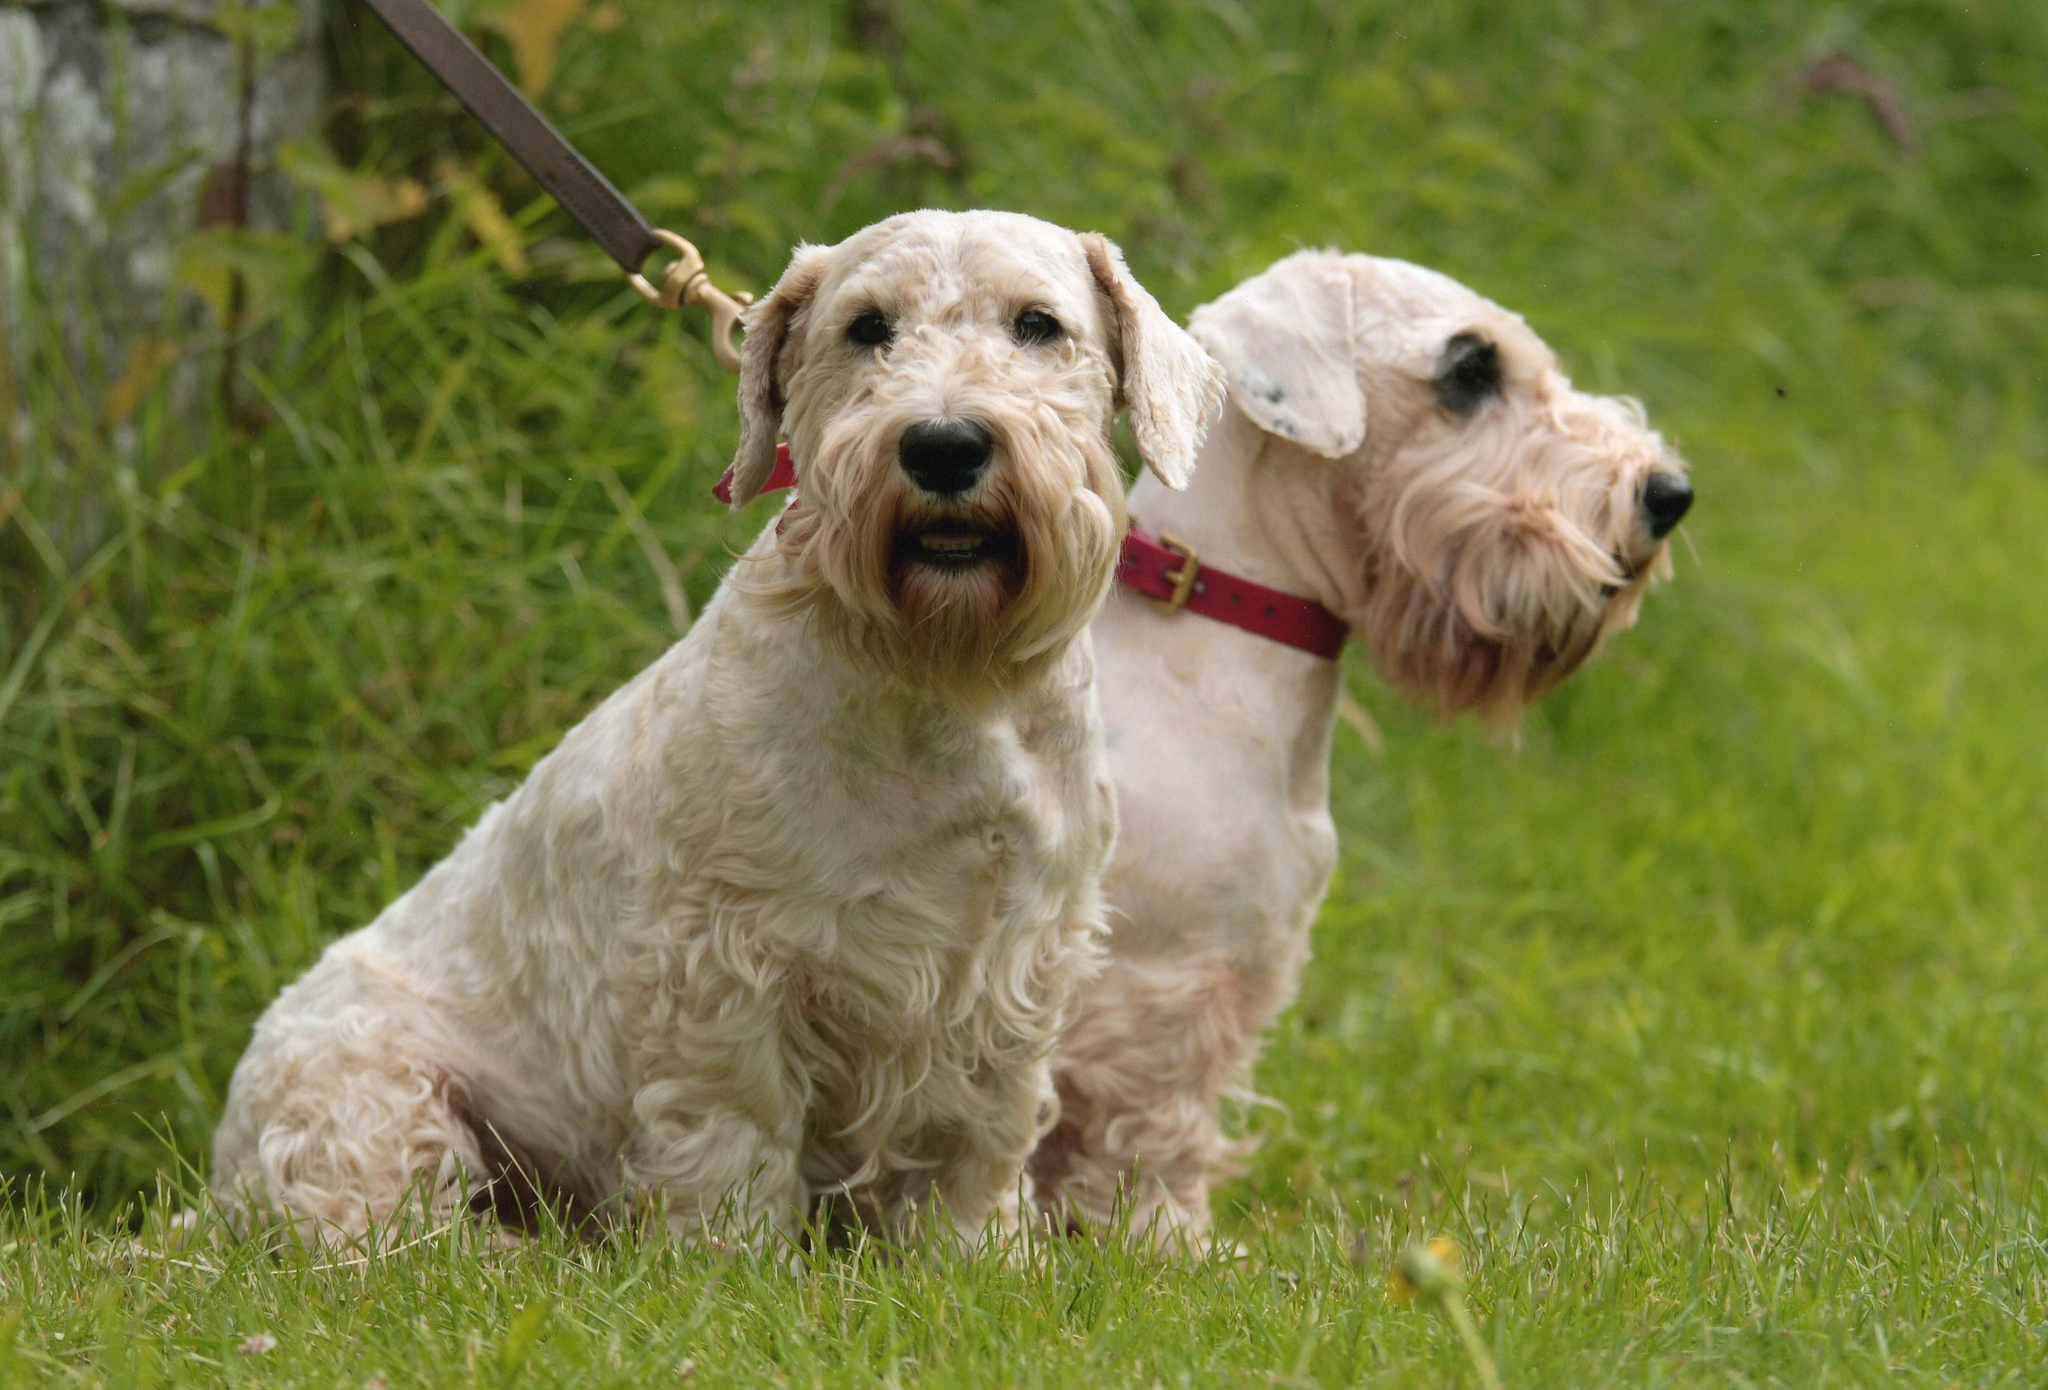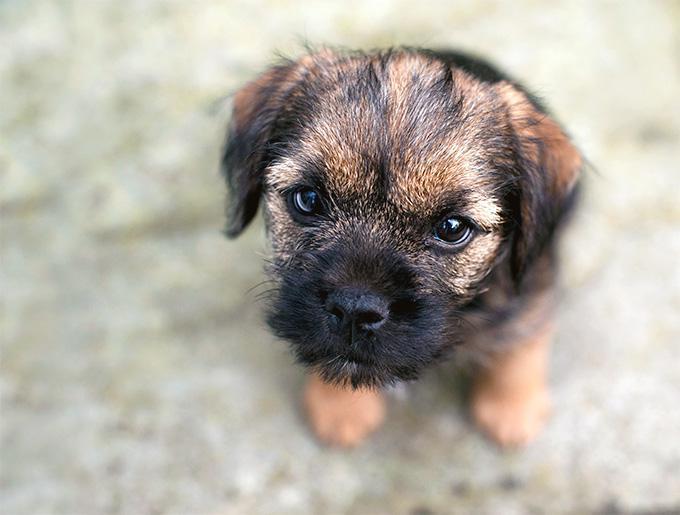The first image is the image on the left, the second image is the image on the right. Analyze the images presented: Is the assertion "At least one dog is wearing a red collar." valid? Answer yes or no. Yes. The first image is the image on the left, the second image is the image on the right. Assess this claim about the two images: "At least one dog is wearing a red collar.". Correct or not? Answer yes or no. Yes. 